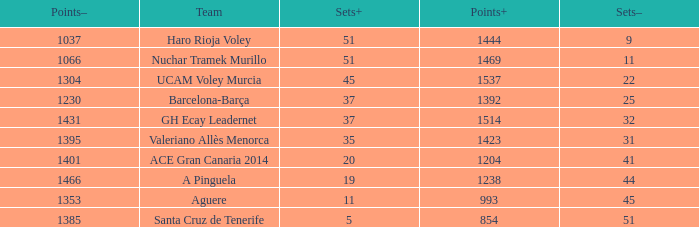What is the total number of Points- when the Sets- is larger than 51? 0.0. 